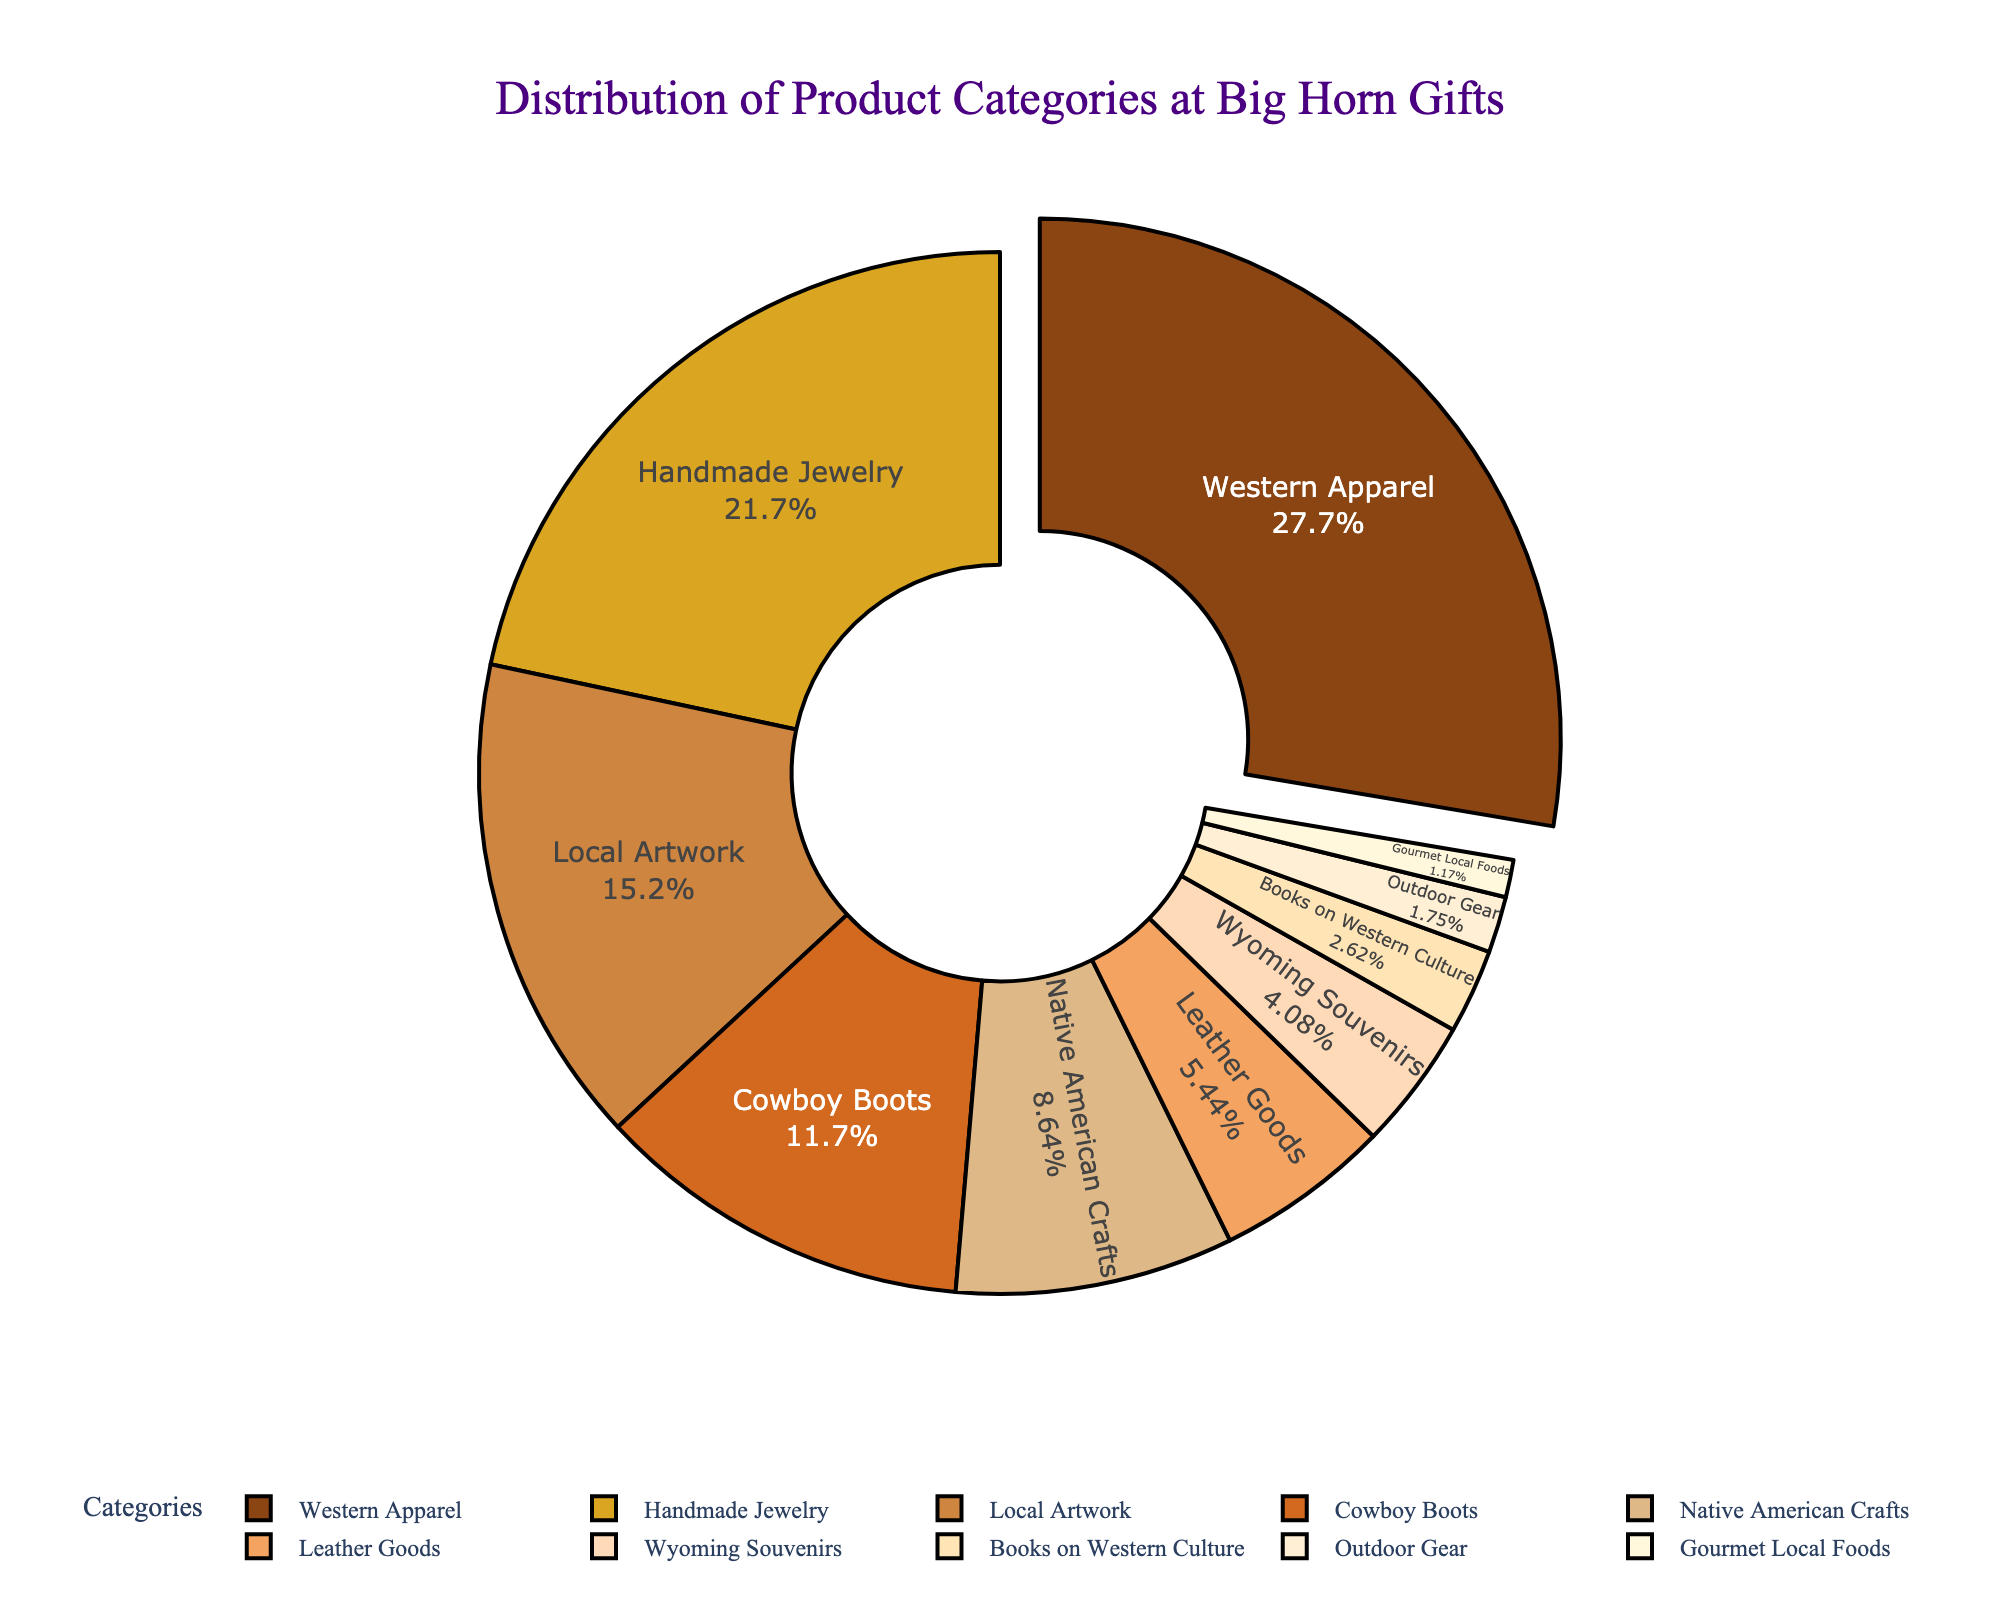What is the most popular product category at Big Horn Gifts? The section labeled "Western Apparel" is the largest part of the pie chart, indicating it has the highest sales volume percentage at 28.5%.
Answer: Western Apparel How much more popular is Western Apparel compared to Handmade Jewelry? Western Apparel holds 28.5% of sales, while Handmade Jewelry has 22.3%. The difference is 28.5% - 22.3% = 6.2%.
Answer: 6.2% Which product category has the smallest sales volume percentage? The smallest section is labeled "Gourmet Local Foods" with 1.2% sales volume.
Answer: Gourmet Local Foods What is the combined sales volume percentage of Local Artwork and Cowboy Boots? Local Artwork has 15.7% and Cowboy Boots have 12.1%. The combined percentage is 15.7% + 12.1% = 27.8%.
Answer: 27.8% Which product category is just below the 10% sales volume mark? "Native American Crafts" is labeled with 8.9%, which is just below the 10% mark.
Answer: Native American Crafts How does the sales volume of Leather Goods compare to Wyoming Souvenirs? Leather Goods have a sales volume percentage of 5.6%, while Wyoming Souvenirs have 4.2%. Leather Goods have a higher sales volume by 5.6% - 4.2% = 1.4%.
Answer: Leather Goods have 1.4% more What is the total contribution of product categories with sales volume percentages below 5%? Wyoming Souvenirs 4.2%, Books on Western Culture 2.7%, Outdoor Gear 1.8%, and Gourmet Local Foods 1.2%. Their total contribution is 4.2% + 2.7% + 1.8% + 1.2% = 9.9%.
Answer: 9.9% Which product categories make up more than 10% of the sales volume each? Western Apparel (28.5%), Handmade Jewelry (22.3%), Local Artwork (15.7%), and Cowboy Boots (12.1%) each make up more than 10% of the sales volume.
Answer: Western Apparel, Handmade Jewelry, Local Artwork, Cowboy Boots What is the average sales volume percentage of the top three most popular categories? The three most popular categories are Western Apparel (28.5%), Handmade Jewelry (22.3%), and Local Artwork (15.7%). Their average sales volume percentage is (28.5% + 22.3% + 15.7%) / 3 = 22.167%.
Answer: 22.167% 